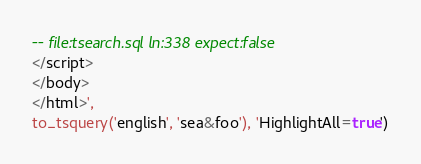<code> <loc_0><loc_0><loc_500><loc_500><_SQL_>-- file:tsearch.sql ln:338 expect:false
</script>
</body>
</html>',
to_tsquery('english', 'sea&foo'), 'HighlightAll=true')
</code> 